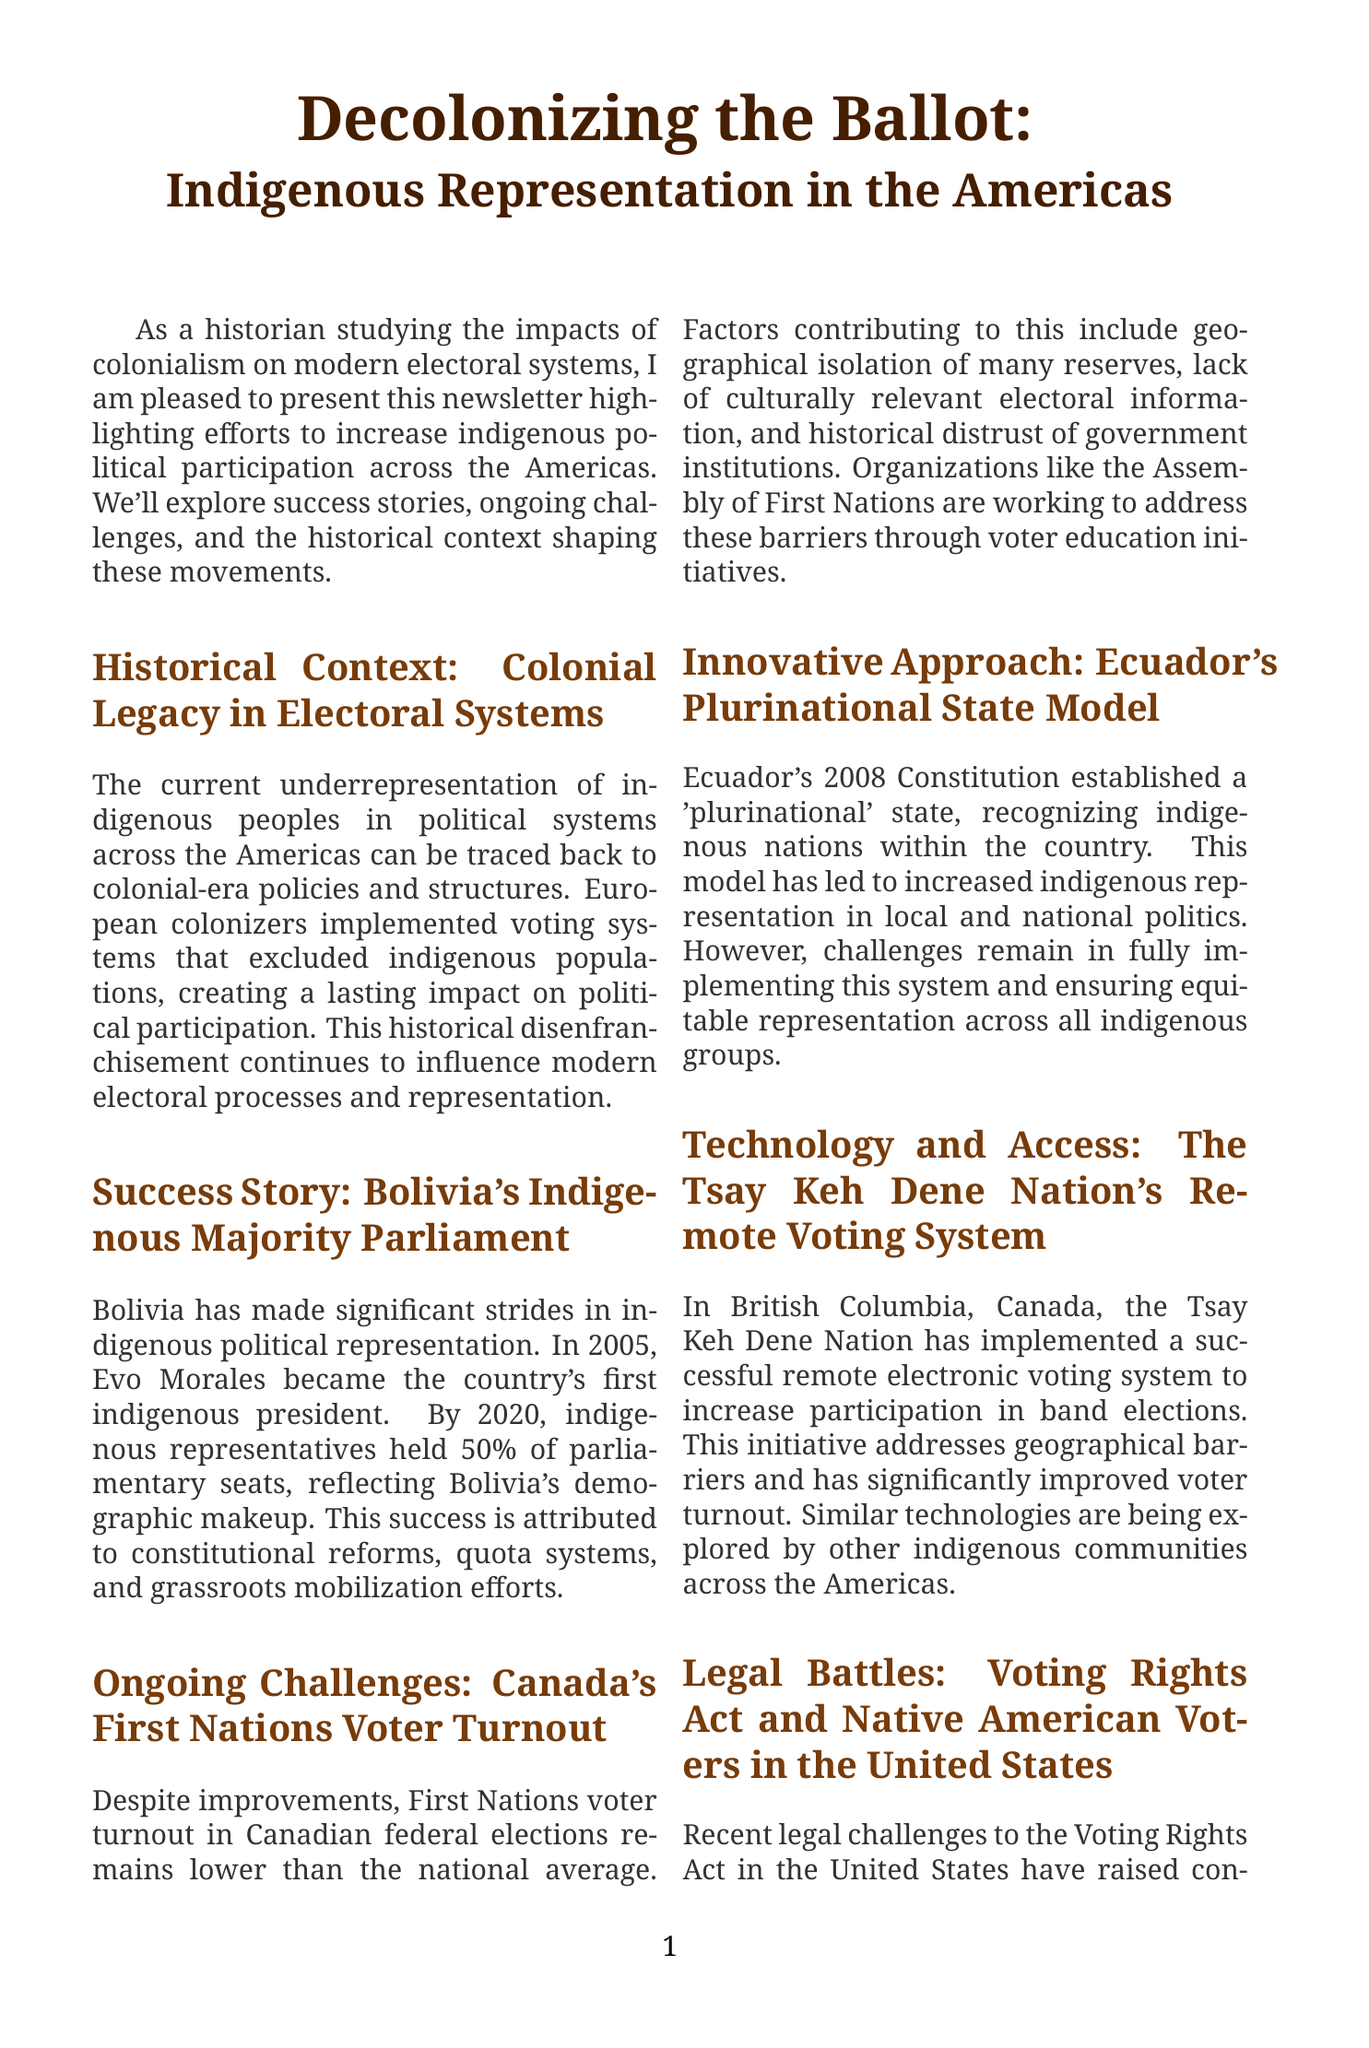What is the title of the newsletter? The title is explicitly provided at the beginning of the document.
Answer: Decolonizing the Ballot: Indigenous Representation in the Americas Who became Bolivia's first indigenous president? The document mentions Evo Morales as the first indigenous president of Bolivia.
Answer: Evo Morales What percentage of parliamentary seats were held by indigenous representatives in Bolivia by 2020? The text states that indigenous representatives held 50% of parliamentary seats by 2020.
Answer: 50% What organization is working to improve voter education for First Nations in Canada? The document identifies the Assembly of First Nations as an organization addressing voter education initiatives.
Answer: Assembly of First Nations What year did Ecuador establish its 'plurinational' state? The document indicates that Ecuador established its plurinational state in 2008.
Answer: 2008 What is one major challenge for First Nations voter turnout in Canada? The document lists several factors, and one of them is geographical isolation of many reserves.
Answer: Geographical isolation What technology has the Tsay Keh Dene Nation implemented for band elections? The document describes a remote electronic voting system implemented by the Tsay Keh Dene Nation.
Answer: Remote electronic voting system What is the goal of the Native American Rights Fund related to voting rights? The document states that the organization is focused on protecting and expanding voting access for indigenous communities.
Answer: Protecting and expanding voting access 